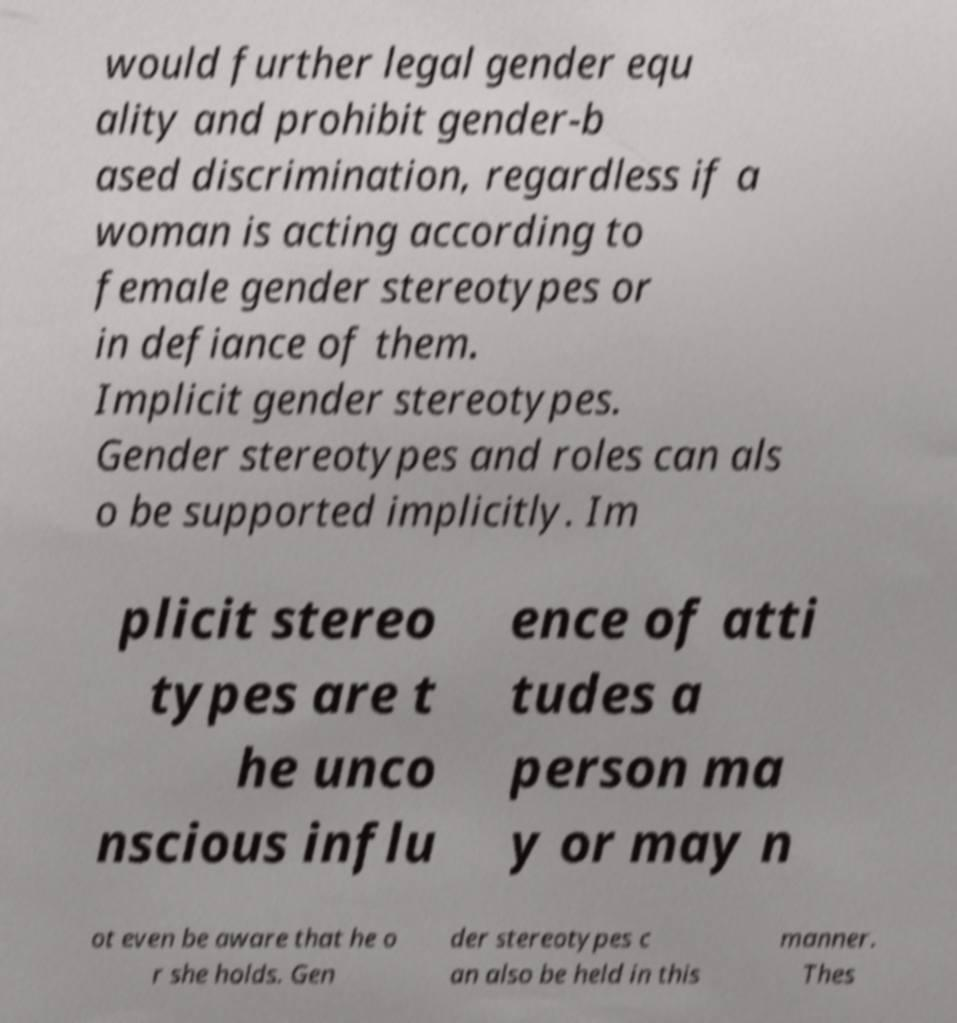What messages or text are displayed in this image? I need them in a readable, typed format. would further legal gender equ ality and prohibit gender-b ased discrimination, regardless if a woman is acting according to female gender stereotypes or in defiance of them. Implicit gender stereotypes. Gender stereotypes and roles can als o be supported implicitly. Im plicit stereo types are t he unco nscious influ ence of atti tudes a person ma y or may n ot even be aware that he o r she holds. Gen der stereotypes c an also be held in this manner. Thes 